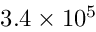<formula> <loc_0><loc_0><loc_500><loc_500>3 . 4 \times 1 0 ^ { 5 }</formula> 